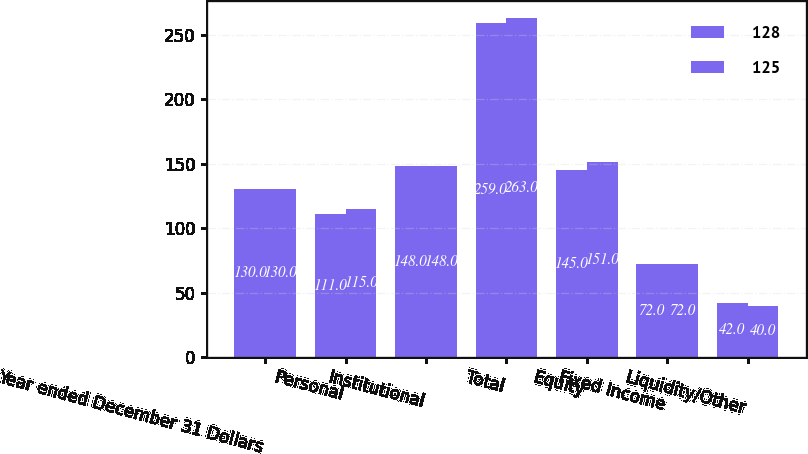<chart> <loc_0><loc_0><loc_500><loc_500><stacked_bar_chart><ecel><fcel>Year ended December 31 Dollars<fcel>Personal<fcel>Institutional<fcel>Total<fcel>Equity<fcel>Fixed Income<fcel>Liquidity/Other<nl><fcel>128<fcel>130<fcel>111<fcel>148<fcel>259<fcel>145<fcel>72<fcel>42<nl><fcel>125<fcel>130<fcel>115<fcel>148<fcel>263<fcel>151<fcel>72<fcel>40<nl></chart> 